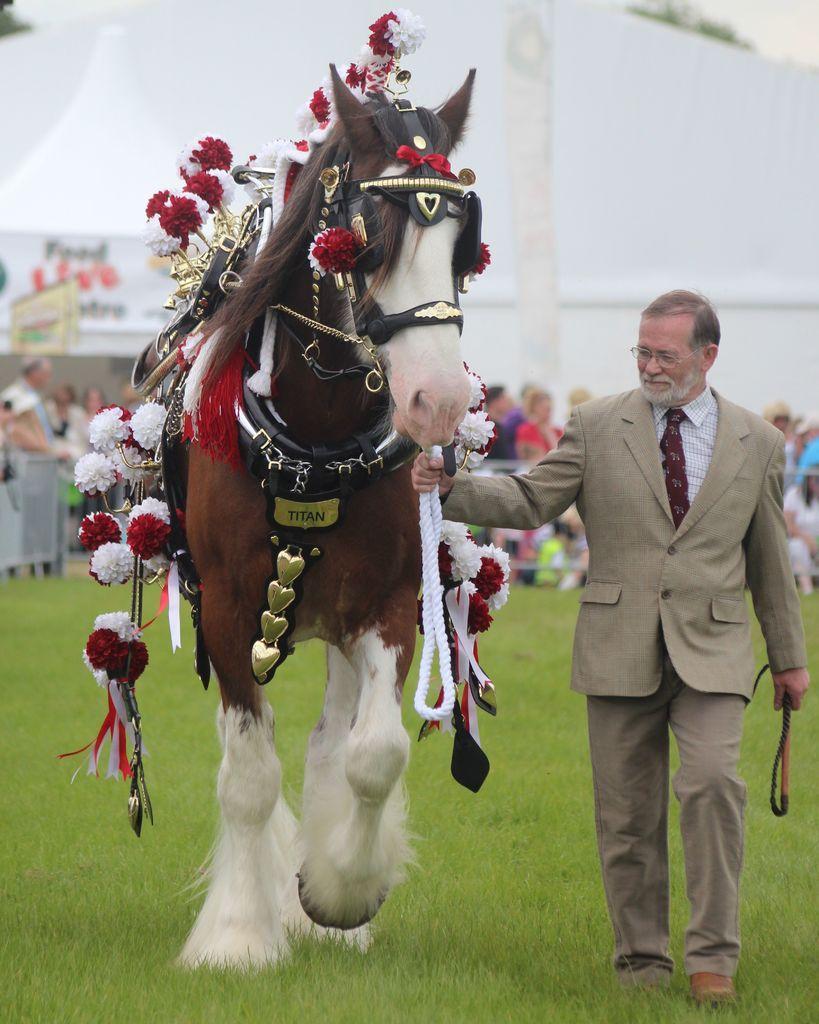Can you describe this image briefly? In this image, there is a horse which is in brown color, there are some artificial flowers on the horse, in the right side there is a old man holding a horse and he is walking, in the background there are some people standing and there is a white color wall. 